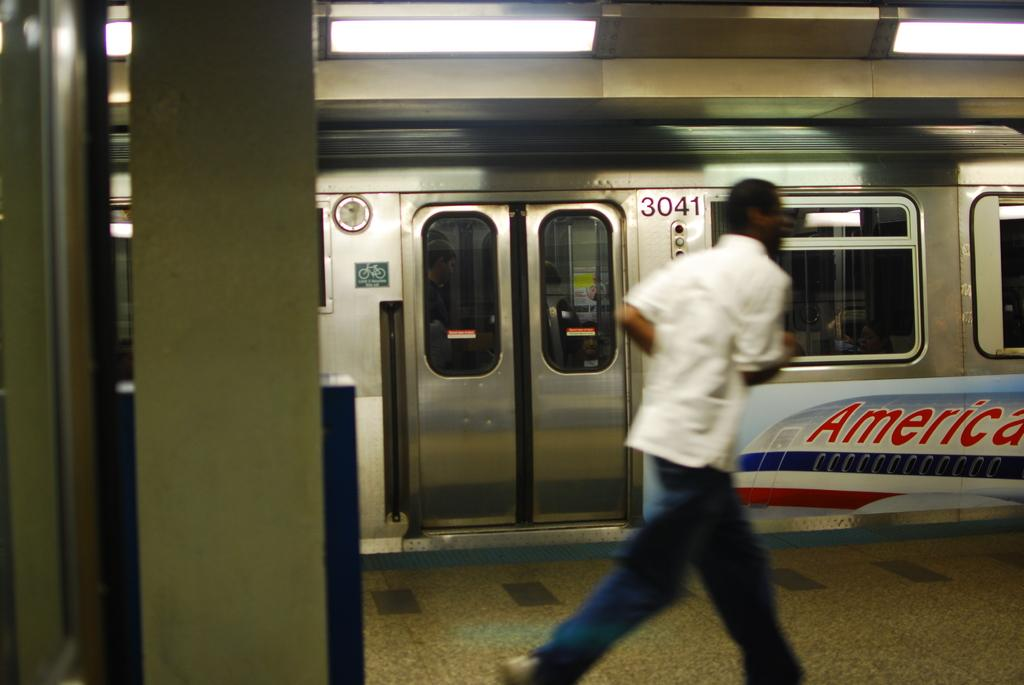What is the person in the image wearing? The person is wearing a white shirt and blue jeans. What is the person doing in the image? The person is running on a platform. What can be seen behind the person? There is a train behind the person. What type of lighting is present on the platform? There are lights on the ceiling of the platform. What type of root can be seen growing on the person's shirt in the image? There is no root growing on the person's shirt in the image. How does the person's pain affect their running in the image? There is no indication of pain in the image, so it cannot be determined how it might affect the person's running. 